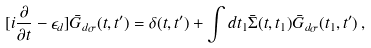Convert formula to latex. <formula><loc_0><loc_0><loc_500><loc_500>[ i { \frac { \partial } { \partial t } } - \epsilon _ { d } ] \bar { G } _ { d \sigma } ( t , t ^ { \prime } ) = \delta ( t , t ^ { \prime } ) + \int d t _ { 1 } \bar { \Sigma } ( t , t _ { 1 } ) \bar { G } _ { d \sigma } ( t _ { 1 } , t ^ { \prime } ) \, ,</formula> 